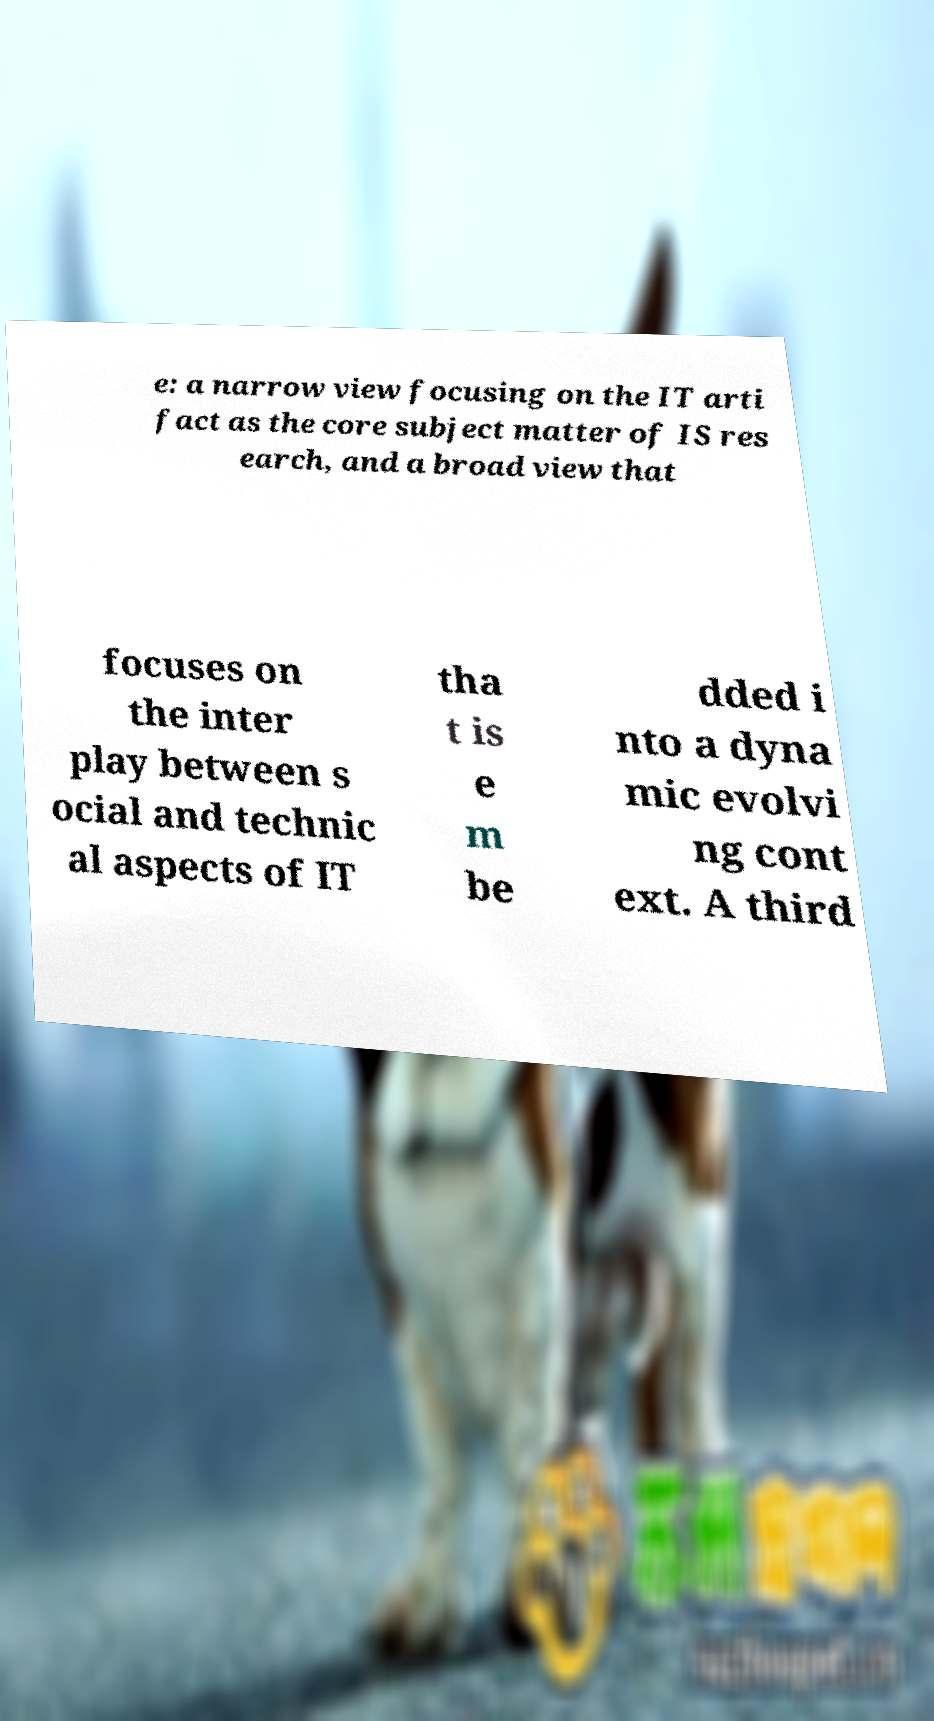What messages or text are displayed in this image? I need them in a readable, typed format. e: a narrow view focusing on the IT arti fact as the core subject matter of IS res earch, and a broad view that focuses on the inter play between s ocial and technic al aspects of IT tha t is e m be dded i nto a dyna mic evolvi ng cont ext. A third 